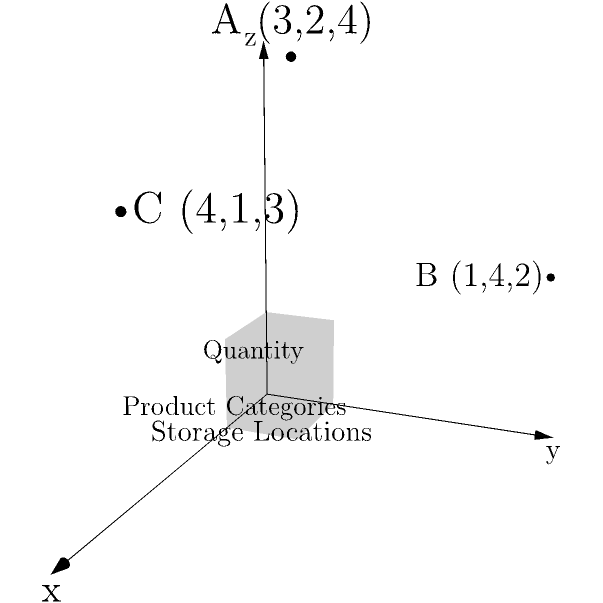As the head of a local small business association, you're helping members visualize their warehouse inventory using a 3D coordinate system. In this system, the x-axis represents product categories, the y-axis represents storage locations, and the z-axis represents quantity. Three products A(3,2,4), B(1,4,2), and C(4,1,3) are shown. What is the total quantity of all products represented in this visualization? To find the total quantity of all products, we need to sum the z-coordinates of each point, as the z-axis represents quantity. Let's break it down step-by-step:

1. Point A: (3,2,4)
   The z-coordinate (quantity) is 4.

2. Point B: (1,4,2)
   The z-coordinate (quantity) is 2.

3. Point C: (4,1,3)
   The z-coordinate (quantity) is 3.

4. Sum up all the quantities:
   $4 + 2 + 3 = 9$

Therefore, the total quantity of all products represented in this 3D visualization is 9.
Answer: 9 